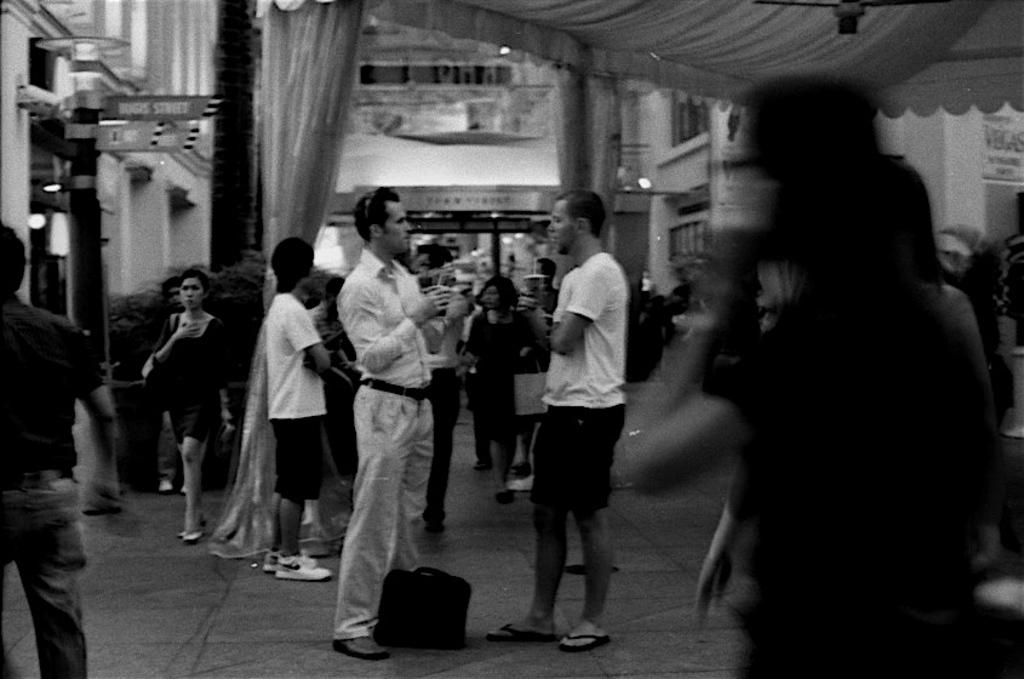Who or what can be seen in the image? There are people in the image. What object is placed on the floor? There is a bag placed on the floor. What can be seen in the background of the image? There is a tent, a building, and lights in the background of the image. Where is the board located in the image? The board is on the left side of the image. What type of carpenter work can be seen on the board in the image? There is no carpenter work or any indication of carpentry on the board in the image. What kind of cloud formation is visible in the image? There is no cloud formation visible in the image; it only shows a tent, a building, and lights in the background. 